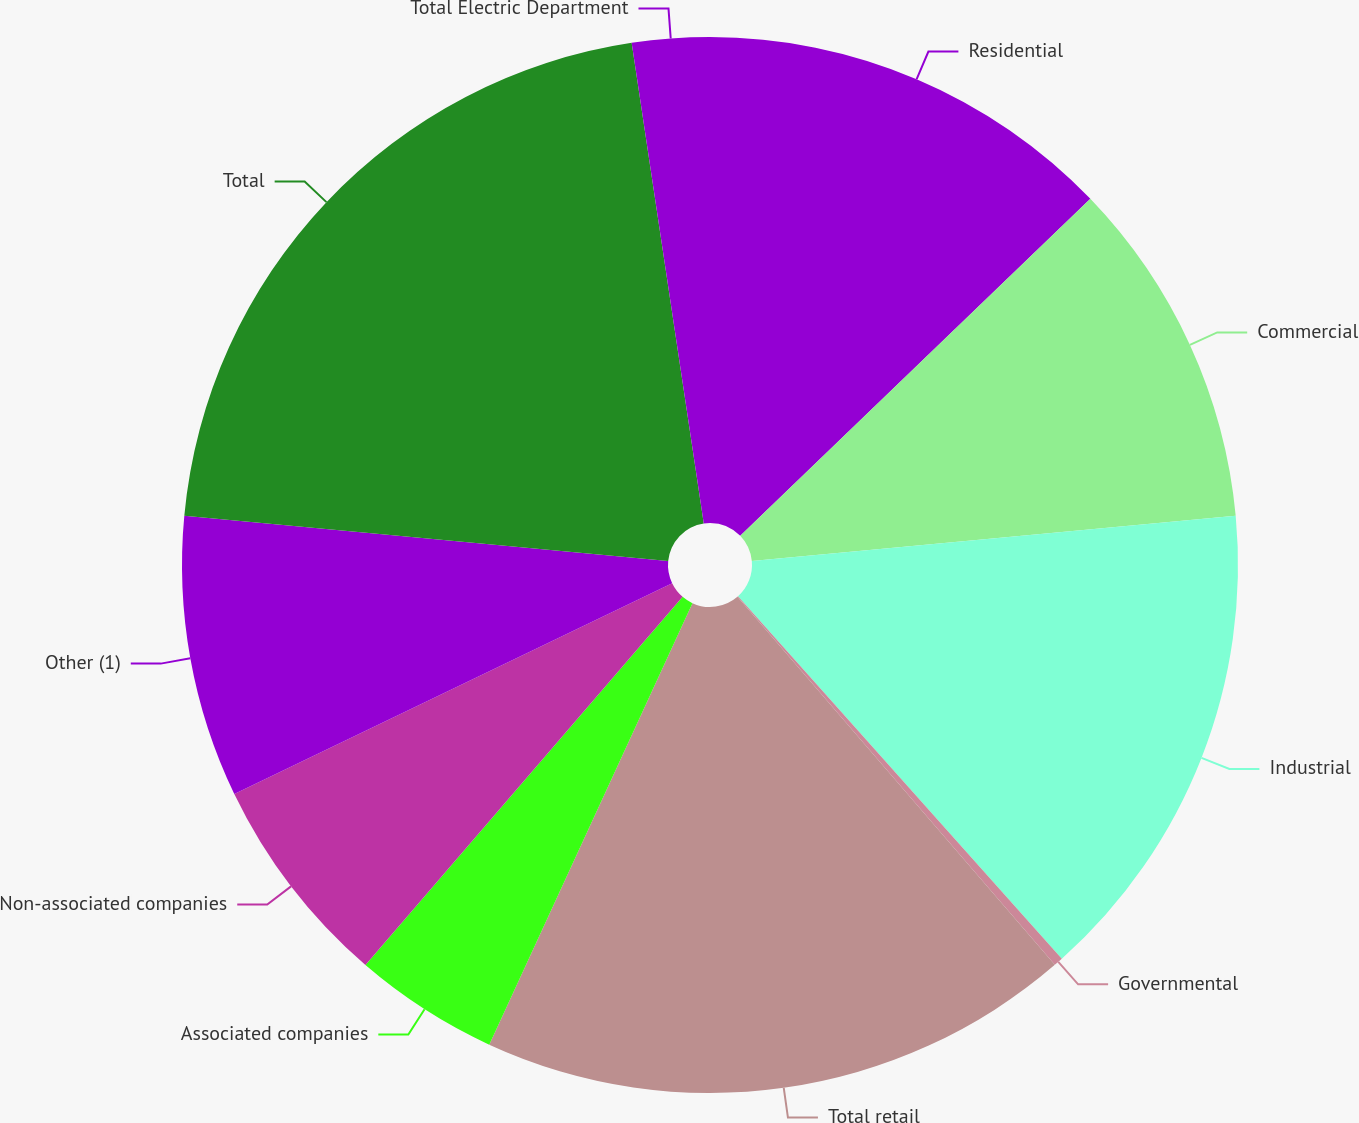<chart> <loc_0><loc_0><loc_500><loc_500><pie_chart><fcel>Residential<fcel>Commercial<fcel>Industrial<fcel>Governmental<fcel>Total retail<fcel>Associated companies<fcel>Non-associated companies<fcel>Other (1)<fcel>Total<fcel>Total Electric Department<nl><fcel>12.8%<fcel>10.71%<fcel>14.88%<fcel>0.28%<fcel>18.19%<fcel>4.45%<fcel>6.54%<fcel>8.63%<fcel>21.14%<fcel>2.37%<nl></chart> 